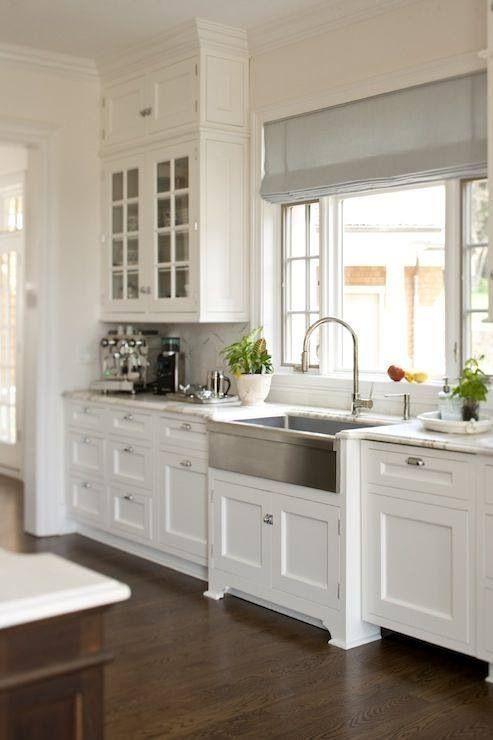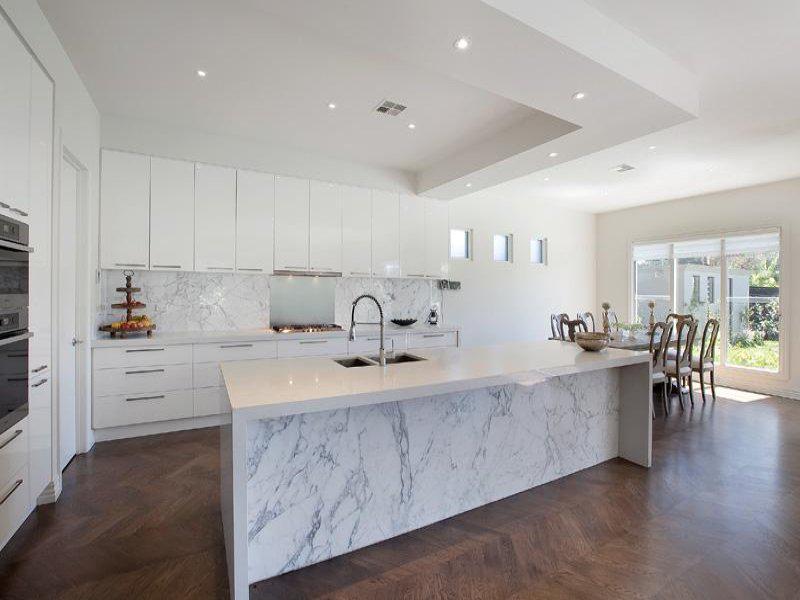The first image is the image on the left, the second image is the image on the right. For the images displayed, is the sentence "In one image, a stainless steel kitchen sink with arc spout is set on a white base cabinet." factually correct? Answer yes or no. Yes. The first image is the image on the left, the second image is the image on the right. For the images shown, is this caption "An island with a white counter sits in the middle of a kitchen." true? Answer yes or no. Yes. 